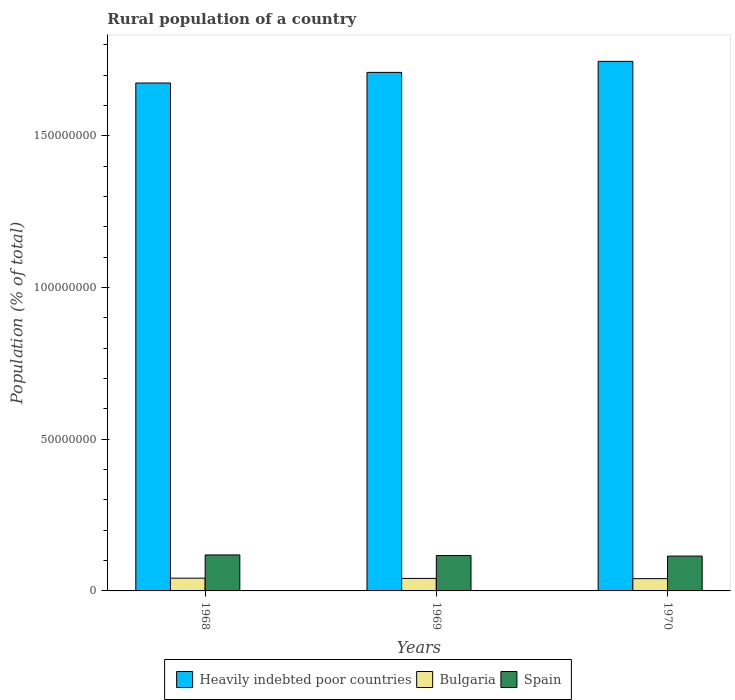Are the number of bars per tick equal to the number of legend labels?
Offer a terse response. Yes. How many bars are there on the 2nd tick from the left?
Provide a succinct answer. 3. What is the label of the 2nd group of bars from the left?
Provide a short and direct response. 1969. In how many cases, is the number of bars for a given year not equal to the number of legend labels?
Provide a short and direct response. 0. What is the rural population in Bulgaria in 1970?
Your answer should be compact. 4.05e+06. Across all years, what is the maximum rural population in Heavily indebted poor countries?
Offer a terse response. 1.75e+08. Across all years, what is the minimum rural population in Bulgaria?
Provide a succinct answer. 4.05e+06. In which year was the rural population in Spain maximum?
Provide a succinct answer. 1968. In which year was the rural population in Spain minimum?
Your response must be concise. 1970. What is the total rural population in Heavily indebted poor countries in the graph?
Offer a terse response. 5.13e+08. What is the difference between the rural population in Bulgaria in 1968 and that in 1970?
Your answer should be very brief. 1.55e+05. What is the difference between the rural population in Spain in 1968 and the rural population in Bulgaria in 1970?
Keep it short and to the point. 7.82e+06. What is the average rural population in Bulgaria per year?
Ensure brevity in your answer.  4.13e+06. In the year 1970, what is the difference between the rural population in Spain and rural population in Heavily indebted poor countries?
Offer a terse response. -1.63e+08. What is the ratio of the rural population in Heavily indebted poor countries in 1969 to that in 1970?
Provide a short and direct response. 0.98. What is the difference between the highest and the second highest rural population in Bulgaria?
Your response must be concise. 7.43e+04. What is the difference between the highest and the lowest rural population in Spain?
Your response must be concise. 3.81e+05. In how many years, is the rural population in Heavily indebted poor countries greater than the average rural population in Heavily indebted poor countries taken over all years?
Your answer should be very brief. 1. Is the sum of the rural population in Spain in 1969 and 1970 greater than the maximum rural population in Bulgaria across all years?
Make the answer very short. Yes. What does the 3rd bar from the right in 1969 represents?
Make the answer very short. Heavily indebted poor countries. Is it the case that in every year, the sum of the rural population in Heavily indebted poor countries and rural population in Bulgaria is greater than the rural population in Spain?
Keep it short and to the point. Yes. Are all the bars in the graph horizontal?
Keep it short and to the point. No. How many years are there in the graph?
Provide a succinct answer. 3. Are the values on the major ticks of Y-axis written in scientific E-notation?
Offer a terse response. No. Does the graph contain grids?
Ensure brevity in your answer.  No. How many legend labels are there?
Give a very brief answer. 3. How are the legend labels stacked?
Provide a succinct answer. Horizontal. What is the title of the graph?
Your answer should be compact. Rural population of a country. What is the label or title of the X-axis?
Keep it short and to the point. Years. What is the label or title of the Y-axis?
Give a very brief answer. Population (% of total). What is the Population (% of total) of Heavily indebted poor countries in 1968?
Ensure brevity in your answer.  1.67e+08. What is the Population (% of total) in Bulgaria in 1968?
Your answer should be very brief. 4.20e+06. What is the Population (% of total) of Spain in 1968?
Ensure brevity in your answer.  1.19e+07. What is the Population (% of total) in Heavily indebted poor countries in 1969?
Make the answer very short. 1.71e+08. What is the Population (% of total) of Bulgaria in 1969?
Your answer should be compact. 4.13e+06. What is the Population (% of total) in Spain in 1969?
Your answer should be very brief. 1.17e+07. What is the Population (% of total) of Heavily indebted poor countries in 1970?
Your response must be concise. 1.75e+08. What is the Population (% of total) of Bulgaria in 1970?
Your answer should be compact. 4.05e+06. What is the Population (% of total) of Spain in 1970?
Your response must be concise. 1.15e+07. Across all years, what is the maximum Population (% of total) in Heavily indebted poor countries?
Provide a short and direct response. 1.75e+08. Across all years, what is the maximum Population (% of total) of Bulgaria?
Offer a terse response. 4.20e+06. Across all years, what is the maximum Population (% of total) in Spain?
Offer a very short reply. 1.19e+07. Across all years, what is the minimum Population (% of total) of Heavily indebted poor countries?
Ensure brevity in your answer.  1.67e+08. Across all years, what is the minimum Population (% of total) of Bulgaria?
Your answer should be compact. 4.05e+06. Across all years, what is the minimum Population (% of total) of Spain?
Make the answer very short. 1.15e+07. What is the total Population (% of total) in Heavily indebted poor countries in the graph?
Offer a terse response. 5.13e+08. What is the total Population (% of total) of Bulgaria in the graph?
Your answer should be compact. 1.24e+07. What is the total Population (% of total) in Spain in the graph?
Ensure brevity in your answer.  3.50e+07. What is the difference between the Population (% of total) in Heavily indebted poor countries in 1968 and that in 1969?
Your response must be concise. -3.50e+06. What is the difference between the Population (% of total) in Bulgaria in 1968 and that in 1969?
Offer a terse response. 7.43e+04. What is the difference between the Population (% of total) in Spain in 1968 and that in 1969?
Provide a short and direct response. 1.97e+05. What is the difference between the Population (% of total) of Heavily indebted poor countries in 1968 and that in 1970?
Offer a terse response. -7.14e+06. What is the difference between the Population (% of total) of Bulgaria in 1968 and that in 1970?
Ensure brevity in your answer.  1.55e+05. What is the difference between the Population (% of total) of Spain in 1968 and that in 1970?
Ensure brevity in your answer.  3.81e+05. What is the difference between the Population (% of total) in Heavily indebted poor countries in 1969 and that in 1970?
Offer a very short reply. -3.64e+06. What is the difference between the Population (% of total) of Bulgaria in 1969 and that in 1970?
Your answer should be very brief. 8.04e+04. What is the difference between the Population (% of total) of Spain in 1969 and that in 1970?
Provide a succinct answer. 1.84e+05. What is the difference between the Population (% of total) in Heavily indebted poor countries in 1968 and the Population (% of total) in Bulgaria in 1969?
Offer a terse response. 1.63e+08. What is the difference between the Population (% of total) of Heavily indebted poor countries in 1968 and the Population (% of total) of Spain in 1969?
Your response must be concise. 1.56e+08. What is the difference between the Population (% of total) in Bulgaria in 1968 and the Population (% of total) in Spain in 1969?
Make the answer very short. -7.46e+06. What is the difference between the Population (% of total) in Heavily indebted poor countries in 1968 and the Population (% of total) in Bulgaria in 1970?
Your response must be concise. 1.63e+08. What is the difference between the Population (% of total) of Heavily indebted poor countries in 1968 and the Population (% of total) of Spain in 1970?
Your answer should be compact. 1.56e+08. What is the difference between the Population (% of total) of Bulgaria in 1968 and the Population (% of total) of Spain in 1970?
Offer a terse response. -7.28e+06. What is the difference between the Population (% of total) in Heavily indebted poor countries in 1969 and the Population (% of total) in Bulgaria in 1970?
Your answer should be very brief. 1.67e+08. What is the difference between the Population (% of total) of Heavily indebted poor countries in 1969 and the Population (% of total) of Spain in 1970?
Keep it short and to the point. 1.59e+08. What is the difference between the Population (% of total) in Bulgaria in 1969 and the Population (% of total) in Spain in 1970?
Your response must be concise. -7.35e+06. What is the average Population (% of total) of Heavily indebted poor countries per year?
Offer a very short reply. 1.71e+08. What is the average Population (% of total) of Bulgaria per year?
Offer a terse response. 4.13e+06. What is the average Population (% of total) of Spain per year?
Offer a terse response. 1.17e+07. In the year 1968, what is the difference between the Population (% of total) of Heavily indebted poor countries and Population (% of total) of Bulgaria?
Offer a very short reply. 1.63e+08. In the year 1968, what is the difference between the Population (% of total) of Heavily indebted poor countries and Population (% of total) of Spain?
Offer a very short reply. 1.56e+08. In the year 1968, what is the difference between the Population (% of total) in Bulgaria and Population (% of total) in Spain?
Provide a short and direct response. -7.66e+06. In the year 1969, what is the difference between the Population (% of total) in Heavily indebted poor countries and Population (% of total) in Bulgaria?
Give a very brief answer. 1.67e+08. In the year 1969, what is the difference between the Population (% of total) of Heavily indebted poor countries and Population (% of total) of Spain?
Offer a very short reply. 1.59e+08. In the year 1969, what is the difference between the Population (% of total) in Bulgaria and Population (% of total) in Spain?
Provide a short and direct response. -7.54e+06. In the year 1970, what is the difference between the Population (% of total) in Heavily indebted poor countries and Population (% of total) in Bulgaria?
Your response must be concise. 1.71e+08. In the year 1970, what is the difference between the Population (% of total) of Heavily indebted poor countries and Population (% of total) of Spain?
Your answer should be very brief. 1.63e+08. In the year 1970, what is the difference between the Population (% of total) in Bulgaria and Population (% of total) in Spain?
Give a very brief answer. -7.43e+06. What is the ratio of the Population (% of total) of Heavily indebted poor countries in 1968 to that in 1969?
Your response must be concise. 0.98. What is the ratio of the Population (% of total) in Bulgaria in 1968 to that in 1969?
Make the answer very short. 1.02. What is the ratio of the Population (% of total) in Spain in 1968 to that in 1969?
Make the answer very short. 1.02. What is the ratio of the Population (% of total) in Heavily indebted poor countries in 1968 to that in 1970?
Ensure brevity in your answer.  0.96. What is the ratio of the Population (% of total) of Bulgaria in 1968 to that in 1970?
Make the answer very short. 1.04. What is the ratio of the Population (% of total) of Spain in 1968 to that in 1970?
Give a very brief answer. 1.03. What is the ratio of the Population (% of total) in Heavily indebted poor countries in 1969 to that in 1970?
Ensure brevity in your answer.  0.98. What is the ratio of the Population (% of total) of Bulgaria in 1969 to that in 1970?
Make the answer very short. 1.02. What is the ratio of the Population (% of total) of Spain in 1969 to that in 1970?
Offer a very short reply. 1.02. What is the difference between the highest and the second highest Population (% of total) in Heavily indebted poor countries?
Give a very brief answer. 3.64e+06. What is the difference between the highest and the second highest Population (% of total) in Bulgaria?
Give a very brief answer. 7.43e+04. What is the difference between the highest and the second highest Population (% of total) of Spain?
Offer a terse response. 1.97e+05. What is the difference between the highest and the lowest Population (% of total) of Heavily indebted poor countries?
Keep it short and to the point. 7.14e+06. What is the difference between the highest and the lowest Population (% of total) of Bulgaria?
Your answer should be very brief. 1.55e+05. What is the difference between the highest and the lowest Population (% of total) in Spain?
Your answer should be very brief. 3.81e+05. 